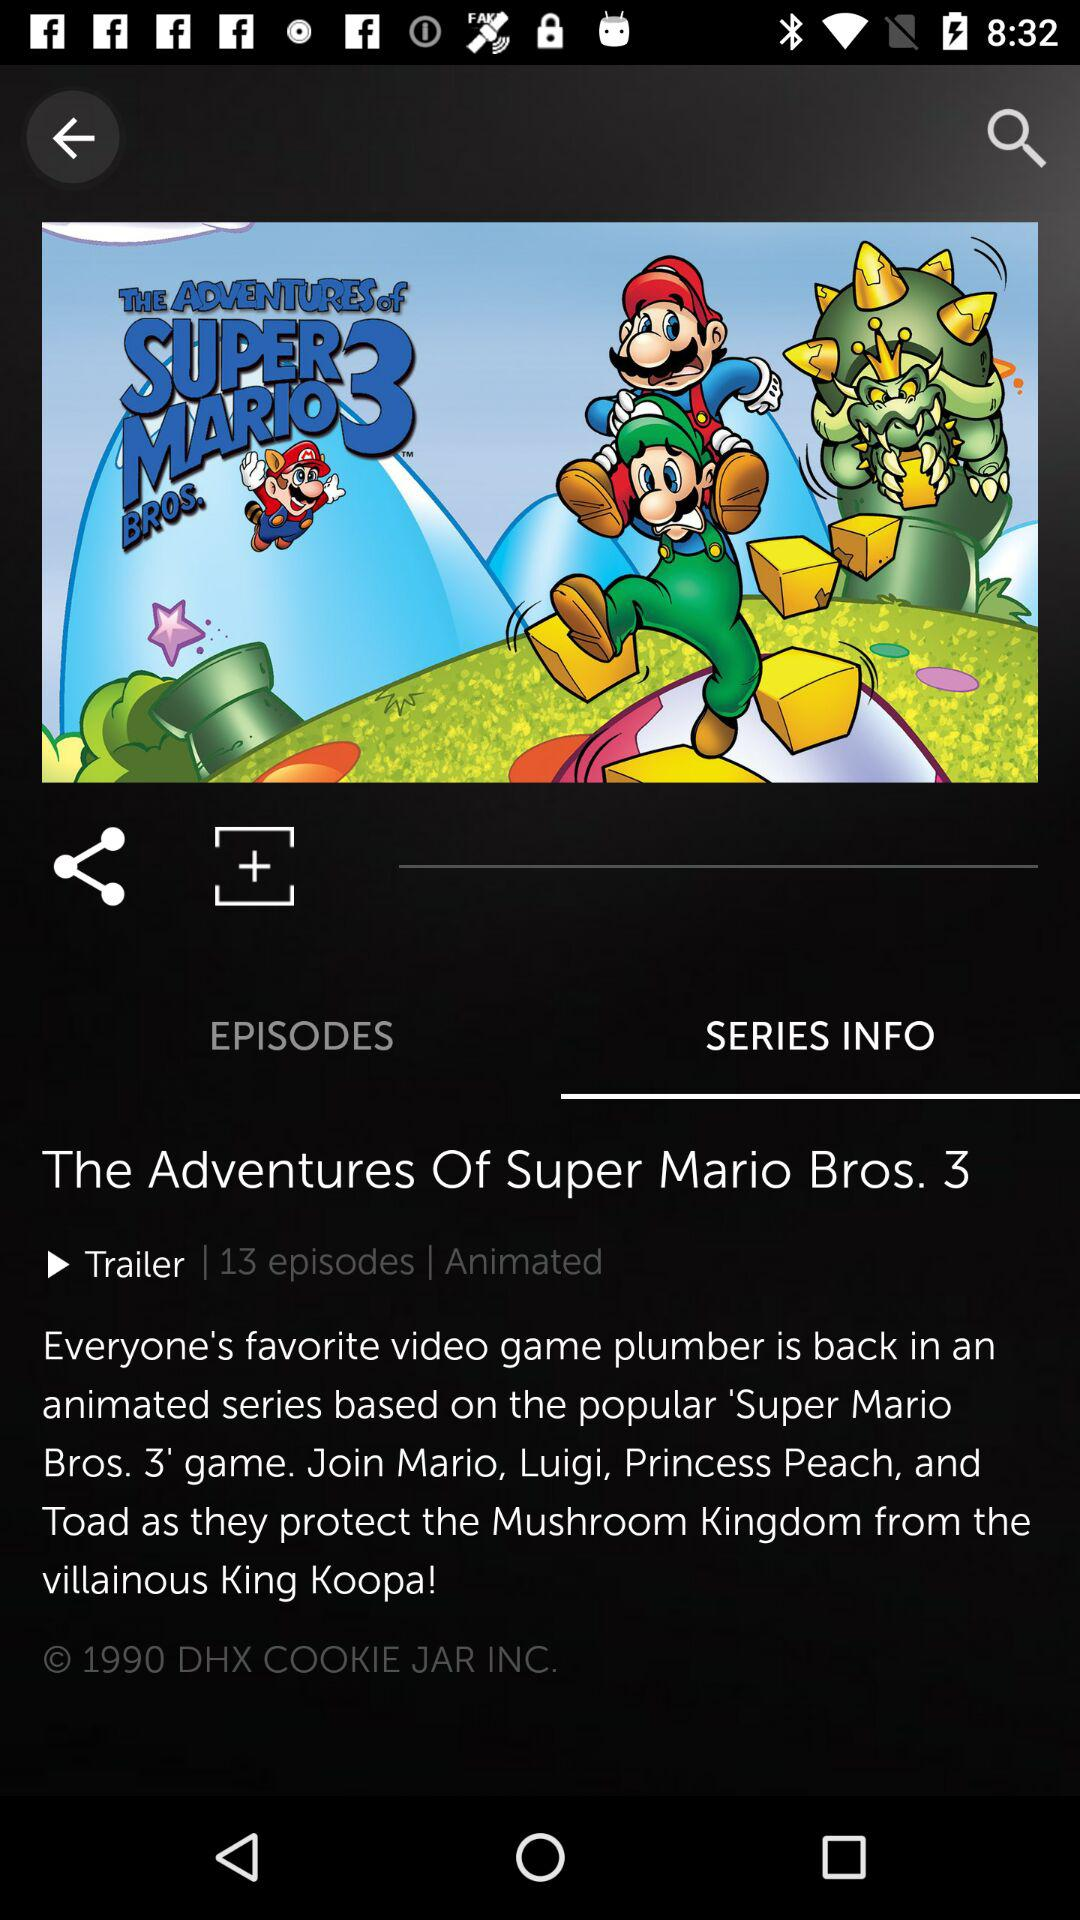Which tab has been selected? The selected tab is "SERIES INFO". 